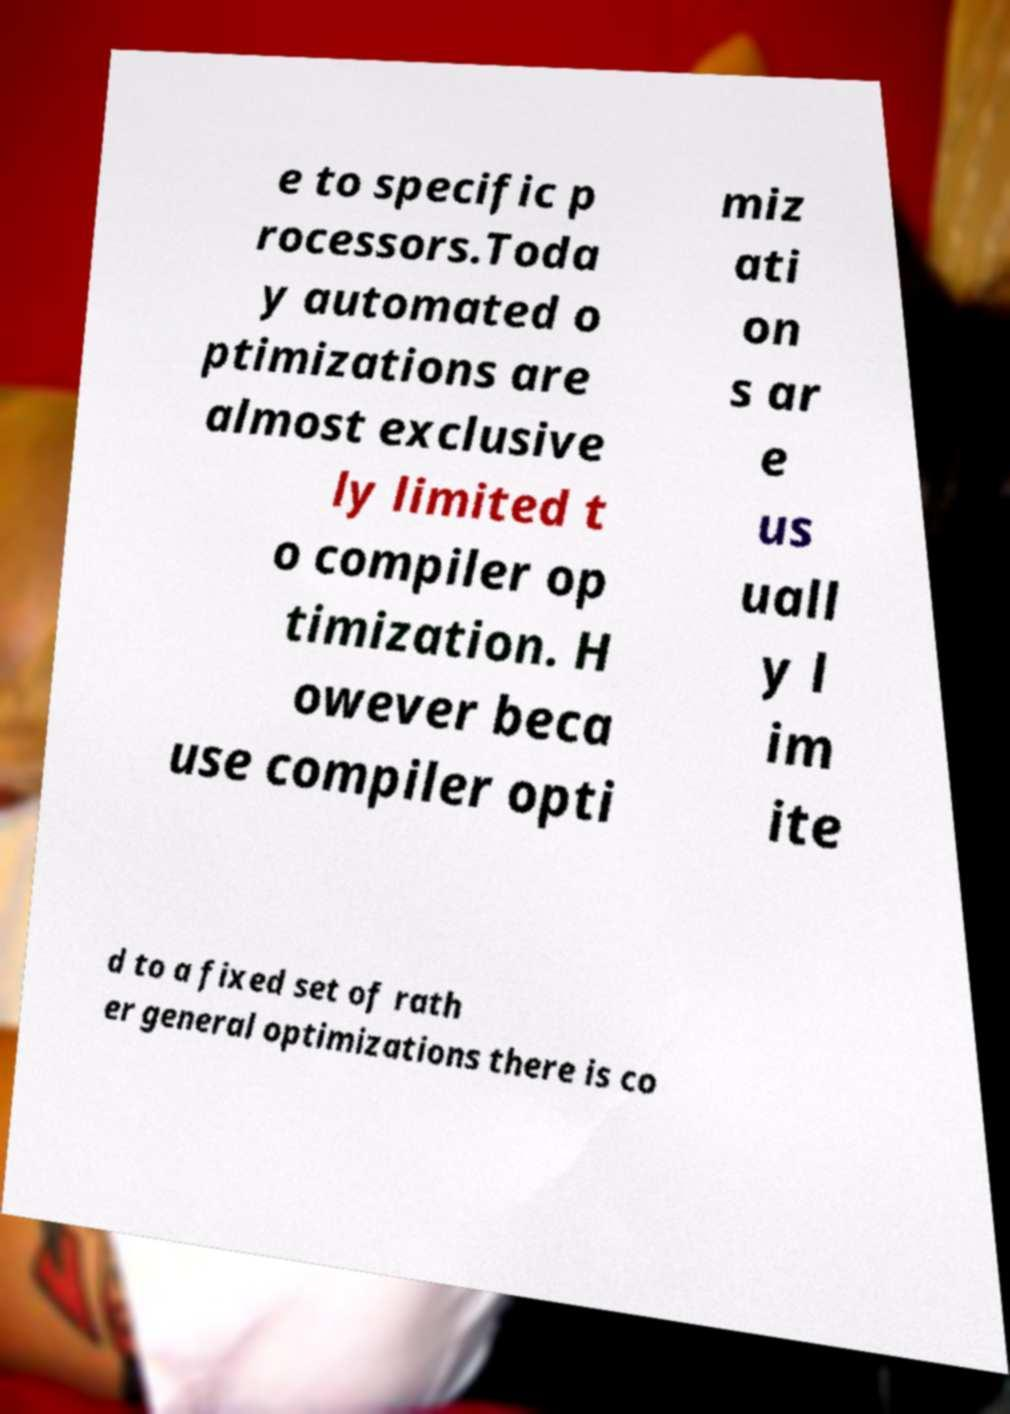I need the written content from this picture converted into text. Can you do that? e to specific p rocessors.Toda y automated o ptimizations are almost exclusive ly limited t o compiler op timization. H owever beca use compiler opti miz ati on s ar e us uall y l im ite d to a fixed set of rath er general optimizations there is co 